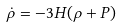<formula> <loc_0><loc_0><loc_500><loc_500>\dot { \rho } = - 3 H ( \rho + P )</formula> 